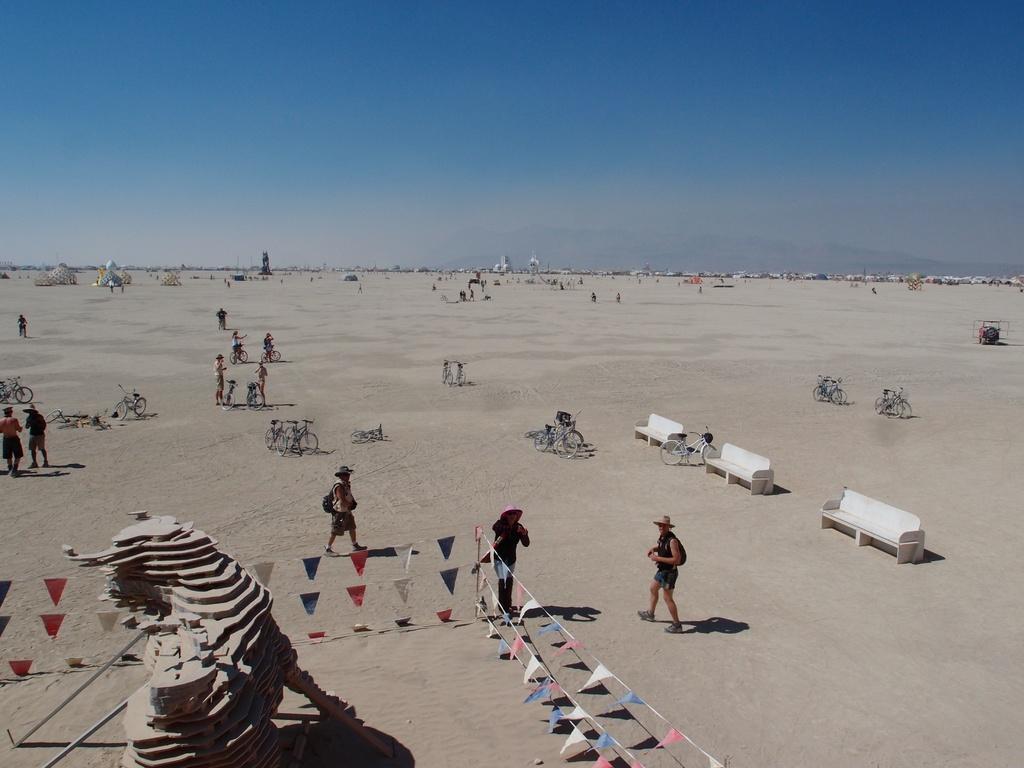How would you summarize this image in a sentence or two? In this picture we can see an art. There are a few color papers on a rope on the left side. We can see a few people, bicycles, benches, tents and other objects on the path. Sky is blue in color. 